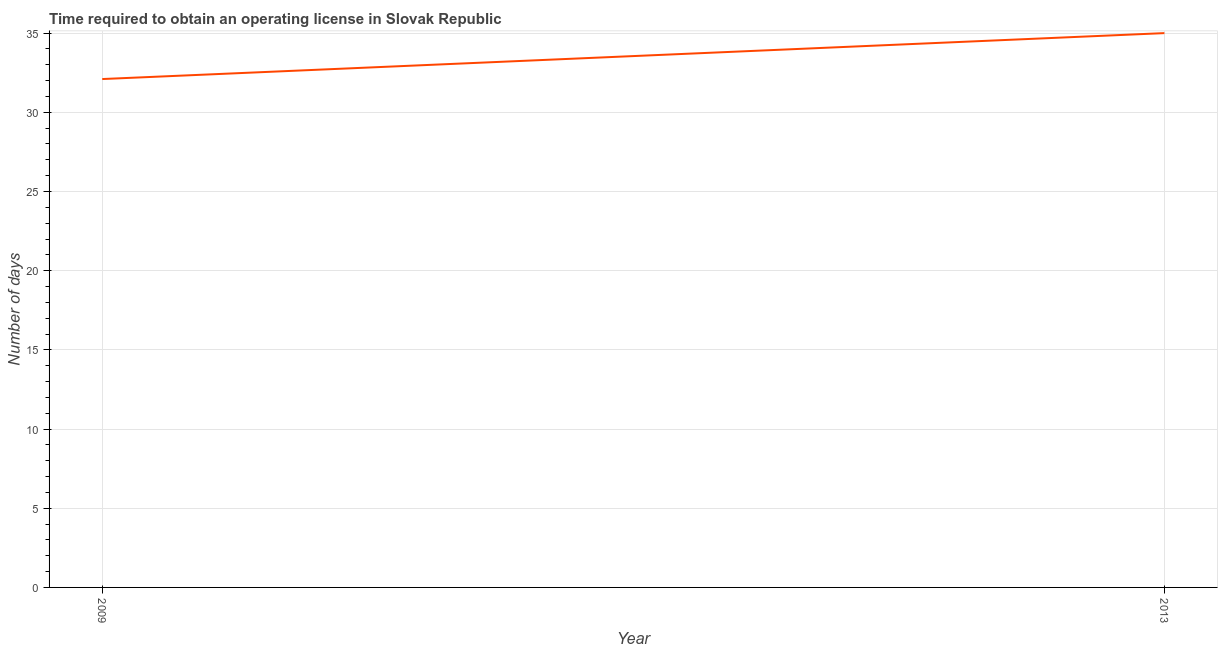What is the number of days to obtain operating license in 2009?
Keep it short and to the point. 32.1. Across all years, what is the minimum number of days to obtain operating license?
Keep it short and to the point. 32.1. In which year was the number of days to obtain operating license minimum?
Offer a terse response. 2009. What is the sum of the number of days to obtain operating license?
Make the answer very short. 67.1. What is the difference between the number of days to obtain operating license in 2009 and 2013?
Offer a terse response. -2.9. What is the average number of days to obtain operating license per year?
Give a very brief answer. 33.55. What is the median number of days to obtain operating license?
Your answer should be very brief. 33.55. In how many years, is the number of days to obtain operating license greater than 34 days?
Provide a short and direct response. 1. Do a majority of the years between 2013 and 2009 (inclusive) have number of days to obtain operating license greater than 21 days?
Give a very brief answer. No. What is the ratio of the number of days to obtain operating license in 2009 to that in 2013?
Offer a very short reply. 0.92. Is the number of days to obtain operating license in 2009 less than that in 2013?
Keep it short and to the point. Yes. In how many years, is the number of days to obtain operating license greater than the average number of days to obtain operating license taken over all years?
Make the answer very short. 1. How many lines are there?
Provide a succinct answer. 1. What is the title of the graph?
Give a very brief answer. Time required to obtain an operating license in Slovak Republic. What is the label or title of the Y-axis?
Your answer should be compact. Number of days. What is the Number of days of 2009?
Provide a succinct answer. 32.1. What is the difference between the Number of days in 2009 and 2013?
Offer a terse response. -2.9. What is the ratio of the Number of days in 2009 to that in 2013?
Make the answer very short. 0.92. 